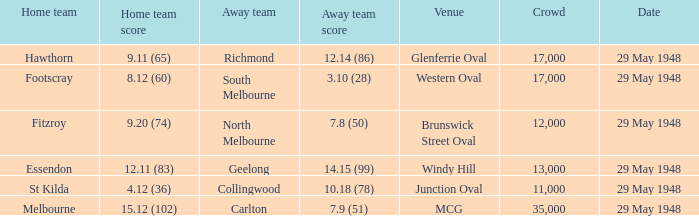During melbourne's home game, who was the away team? Carlton. 